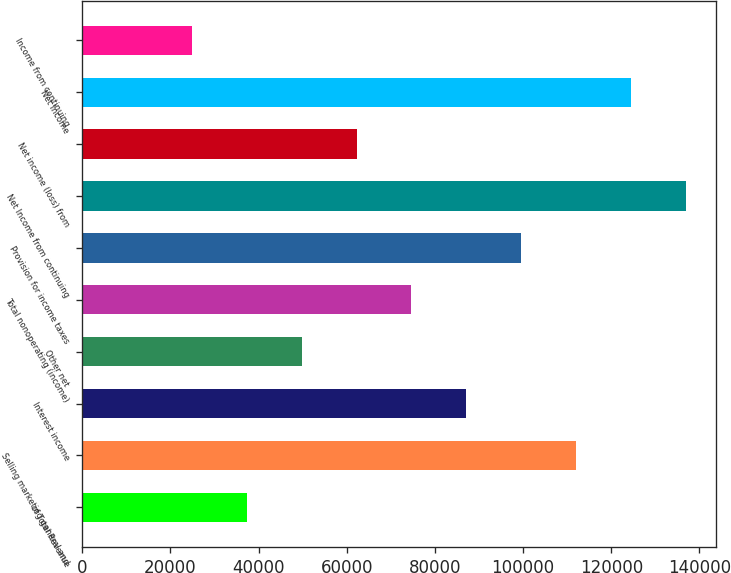<chart> <loc_0><loc_0><loc_500><loc_500><bar_chart><fcel>of Total Revenue<fcel>Selling marketing general and<fcel>Interest income<fcel>Other net<fcel>Total nonoperating (income)<fcel>Provision for income taxes<fcel>Net Income from continuing<fcel>Net income (loss) from<fcel>Net Income<fcel>Income from continuing<nl><fcel>37325.8<fcel>111977<fcel>87093.3<fcel>49767.7<fcel>74651.5<fcel>99535.2<fcel>136861<fcel>62209.6<fcel>124419<fcel>24883.9<nl></chart> 